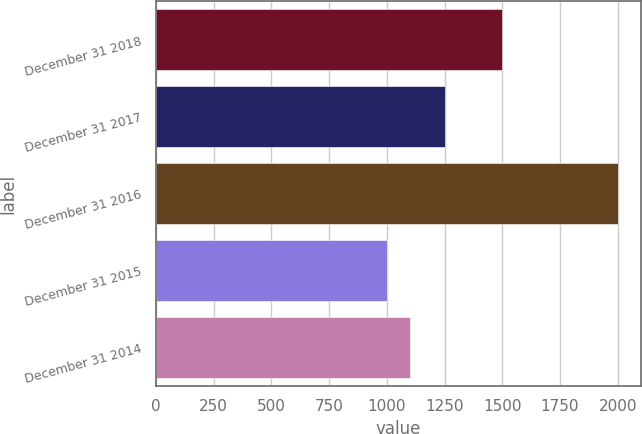Convert chart to OTSL. <chart><loc_0><loc_0><loc_500><loc_500><bar_chart><fcel>December 31 2018<fcel>December 31 2017<fcel>December 31 2016<fcel>December 31 2015<fcel>December 31 2014<nl><fcel>1500<fcel>1250<fcel>2000<fcel>1000<fcel>1100<nl></chart> 